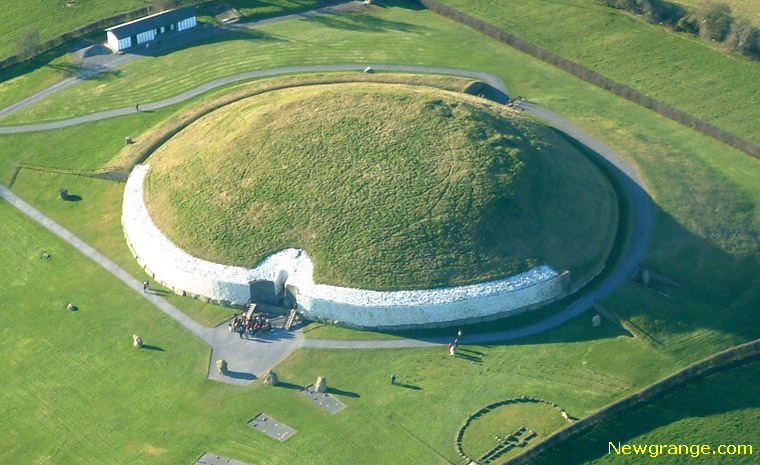What historical significance does Newgrange hold? Newgrange is not just a visually striking monument; it holds immense historical significance. Constructed around 3200 BC, it predates the pyramids of Egypt and Stonehenge. This ancient site is widely believed to have been a burial mound or a ceremonial site. Its architectural ingenuity is highlighted by the fact that it aligns with the rising sun during the winter solstice, illuminating its inner chamber. This astronomical precision suggests advanced knowledge in astronomy among its builders. Newgrange is part of the Brú na Bóinne complex, a UNESCO World Heritage site, and remains an enduring symbol of Neolithic ingenuity and sophistication. 